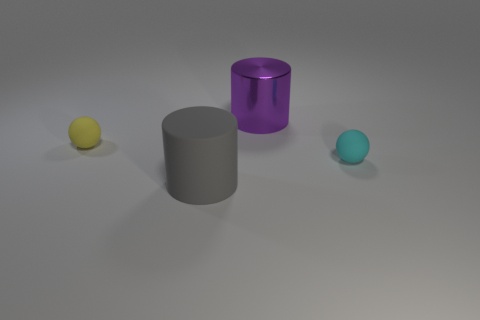There is a large object that is behind the large gray thing; is there a cyan ball on the left side of it?
Offer a very short reply. No. How big is the cyan rubber thing?
Your response must be concise. Small. What number of objects are large gray rubber cylinders or big green rubber cubes?
Give a very brief answer. 1. Do the tiny object that is left of the big purple shiny object and the cylinder that is behind the yellow object have the same material?
Provide a succinct answer. No. The cylinder that is the same material as the tiny cyan thing is what color?
Make the answer very short. Gray. How many yellow objects have the same size as the cyan matte object?
Your response must be concise. 1. Do the small thing left of the large gray matte cylinder and the small thing that is to the right of the big purple cylinder have the same shape?
Ensure brevity in your answer.  Yes. The purple thing that is the same size as the rubber cylinder is what shape?
Offer a very short reply. Cylinder. Is the number of tiny cyan matte spheres that are to the right of the big shiny cylinder the same as the number of big things that are behind the tiny cyan sphere?
Give a very brief answer. Yes. Does the small sphere behind the tiny cyan matte object have the same material as the big gray thing?
Keep it short and to the point. Yes. 